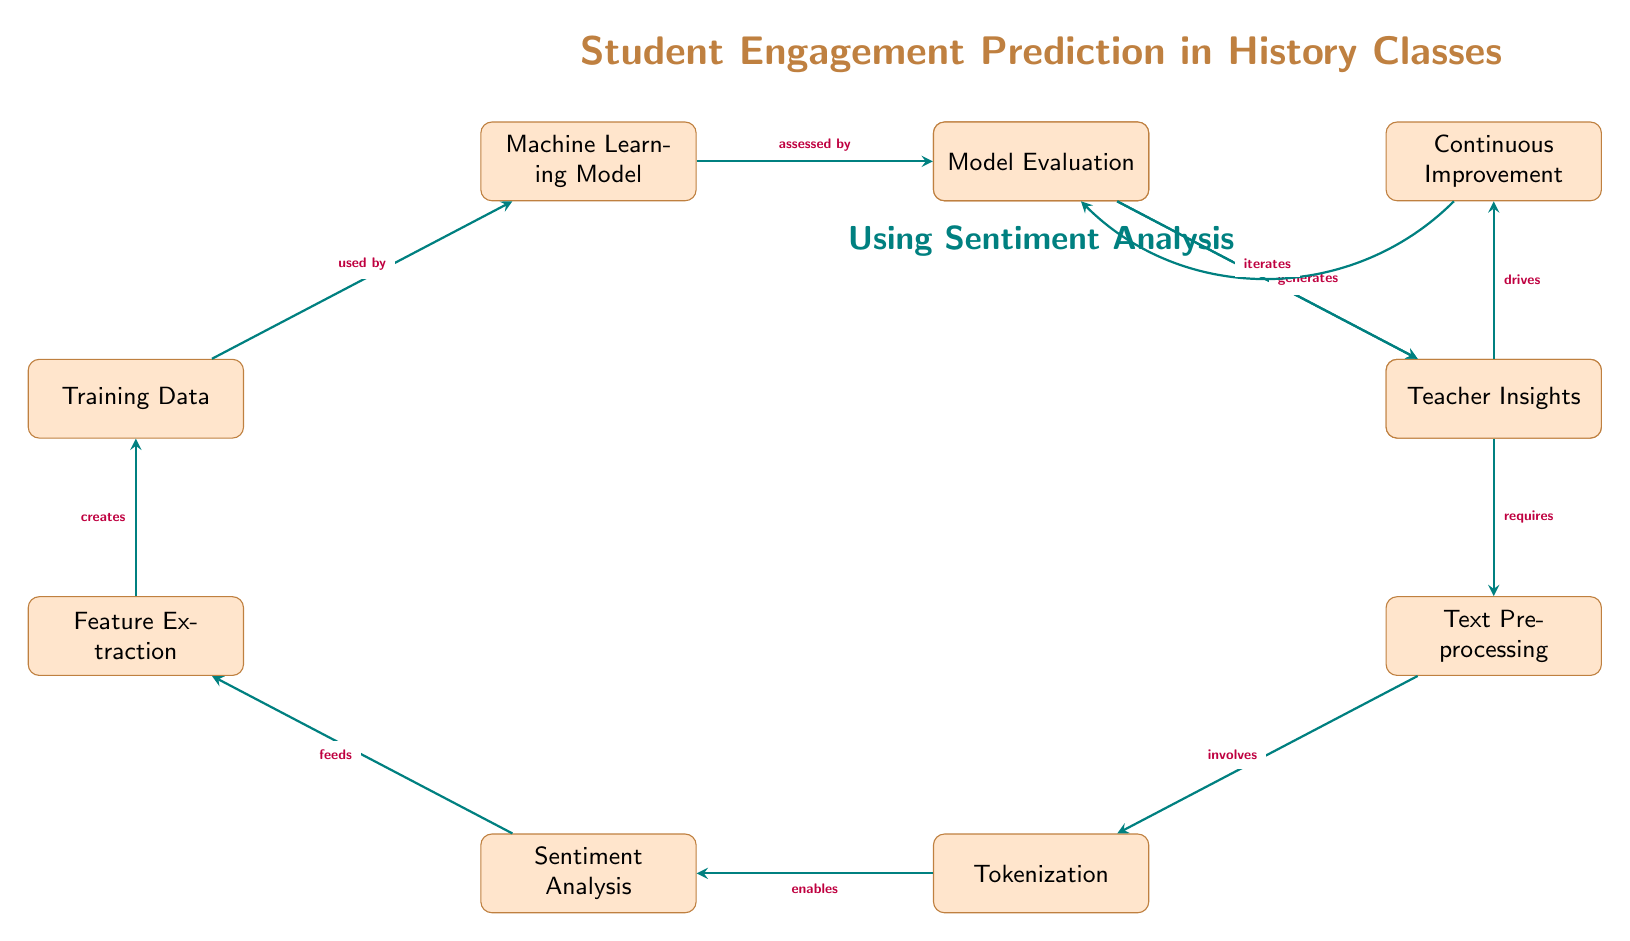What is the first step in the diagram? The diagram starts with the node labeled "Data Collection," which is the first rectangular element in the flow.
Answer: Data Collection How many total nodes are there in the diagram? Counting each rectangular element in the diagram, there are ten nodes, including all steps from data collection to continuous improvement.
Answer: 10 What does the "Tokenization" node enable? The "Tokenization" node feeds into the "Sentiment Analysis" node, indicating that tokenization is a prerequisite for sentiment analysis.
Answer: Sentiment Analysis Which node generates "Teacher Insights"? "Model Evaluation" is the node that directly generates "Teacher Insights," as indicated by the arrow flowing to that node.
Answer: Model Evaluation What step follows "Feature Extraction"? After "Feature Extraction," the next step indicated in the diagram is "Training Data." This shows the direct flow from feature extraction to the training phase.
Answer: Training Data What drives the process of "Continuous Improvement"? The "Teacher Insights" node drives the process of "Continuous Improvement," as shown by the connecting arrow between the two nodes.
Answer: Teacher Insights Which node is assessed by the "Model Evaluation"? The "Machine Learning Model" is assessed by "Model Evaluation," with the arrow indicating that evaluation is based on the results of the machine learning model.
Answer: Machine Learning Model How does "Continuous Improvement" relate back to the process? "Continuous Improvement" iterates back to "Data Collection," indicating a cyclical process where insights lead back to gathering more data.
Answer: Data Collection What is included in the "Data Collection" node? The node "Data Collection" includes various "Feedback Sources," which illustrates that multiple inputs are needed for data collection.
Answer: Feedback Sources 